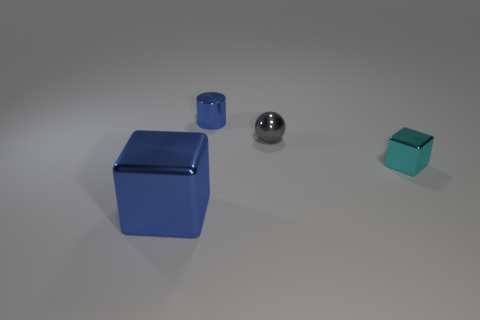Are there more tiny blue cubes than spheres? No, there are not more tiny blue cubes than spheres in the image. In fact, there is one sphere and two cubes present, with the larger blue cube being at the forefront and a smaller blue cube seen further back. 